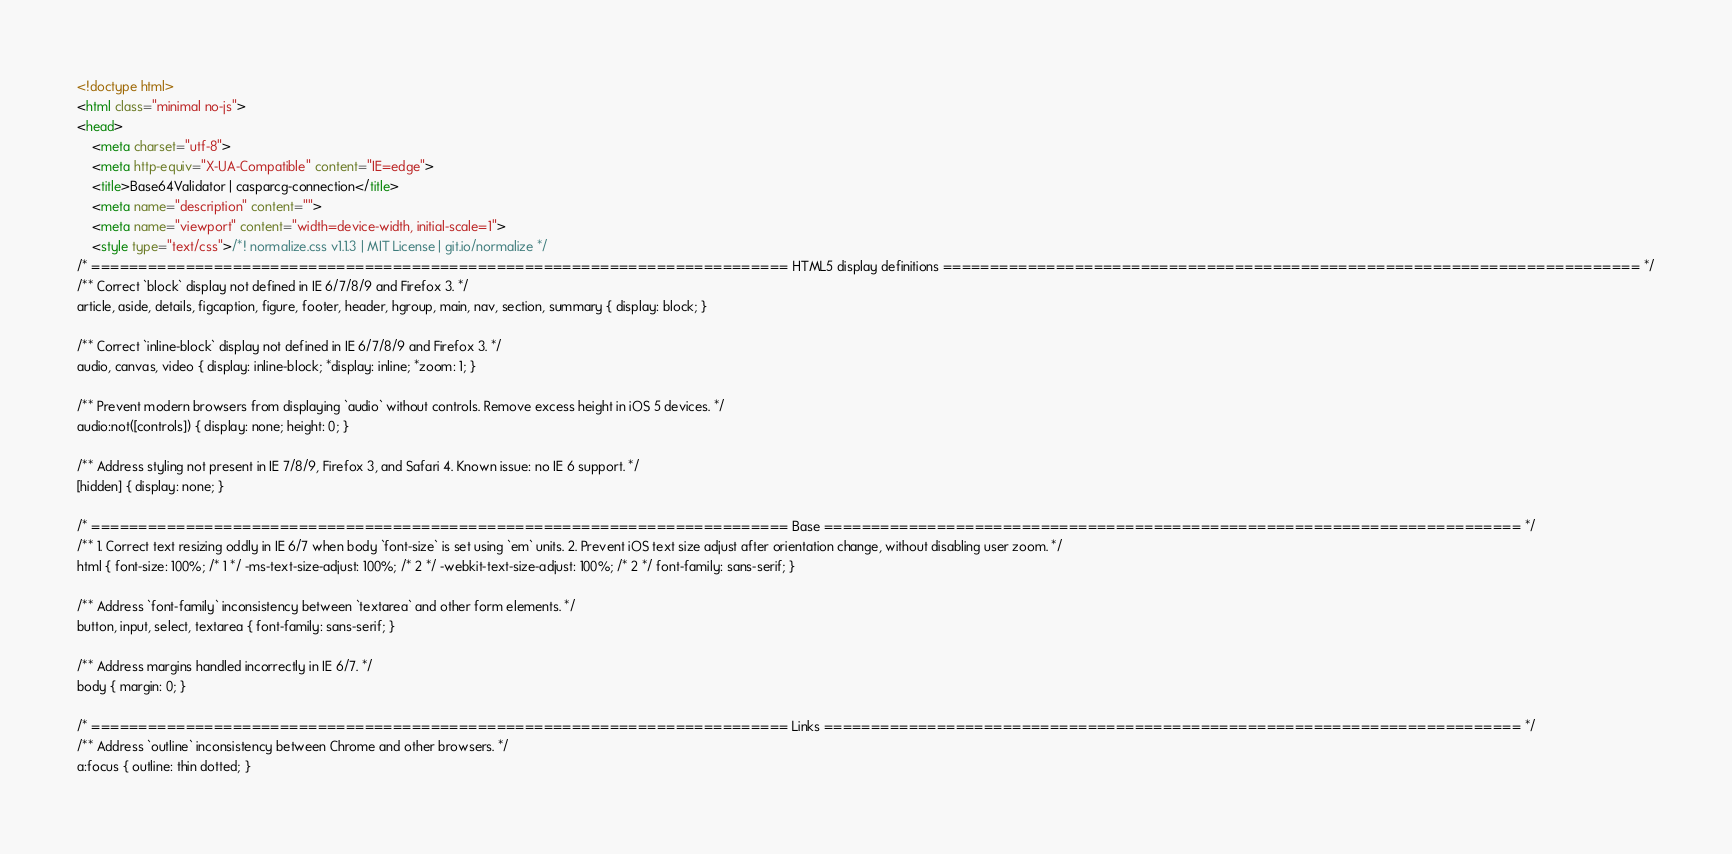Convert code to text. <code><loc_0><loc_0><loc_500><loc_500><_HTML_><!doctype html>
<html class="minimal no-js">
<head>
	<meta charset="utf-8">
	<meta http-equiv="X-UA-Compatible" content="IE=edge">
	<title>Base64Validator | casparcg-connection</title>
	<meta name="description" content="">
	<meta name="viewport" content="width=device-width, initial-scale=1">
	<style type="text/css">/*! normalize.css v1.1.3 | MIT License | git.io/normalize */
/* ========================================================================== HTML5 display definitions ========================================================================== */
/** Correct `block` display not defined in IE 6/7/8/9 and Firefox 3. */
article, aside, details, figcaption, figure, footer, header, hgroup, main, nav, section, summary { display: block; }

/** Correct `inline-block` display not defined in IE 6/7/8/9 and Firefox 3. */
audio, canvas, video { display: inline-block; *display: inline; *zoom: 1; }

/** Prevent modern browsers from displaying `audio` without controls. Remove excess height in iOS 5 devices. */
audio:not([controls]) { display: none; height: 0; }

/** Address styling not present in IE 7/8/9, Firefox 3, and Safari 4. Known issue: no IE 6 support. */
[hidden] { display: none; }

/* ========================================================================== Base ========================================================================== */
/** 1. Correct text resizing oddly in IE 6/7 when body `font-size` is set using `em` units. 2. Prevent iOS text size adjust after orientation change, without disabling user zoom. */
html { font-size: 100%; /* 1 */ -ms-text-size-adjust: 100%; /* 2 */ -webkit-text-size-adjust: 100%; /* 2 */ font-family: sans-serif; }

/** Address `font-family` inconsistency between `textarea` and other form elements. */
button, input, select, textarea { font-family: sans-serif; }

/** Address margins handled incorrectly in IE 6/7. */
body { margin: 0; }

/* ========================================================================== Links ========================================================================== */
/** Address `outline` inconsistency between Chrome and other browsers. */
a:focus { outline: thin dotted; }</code> 